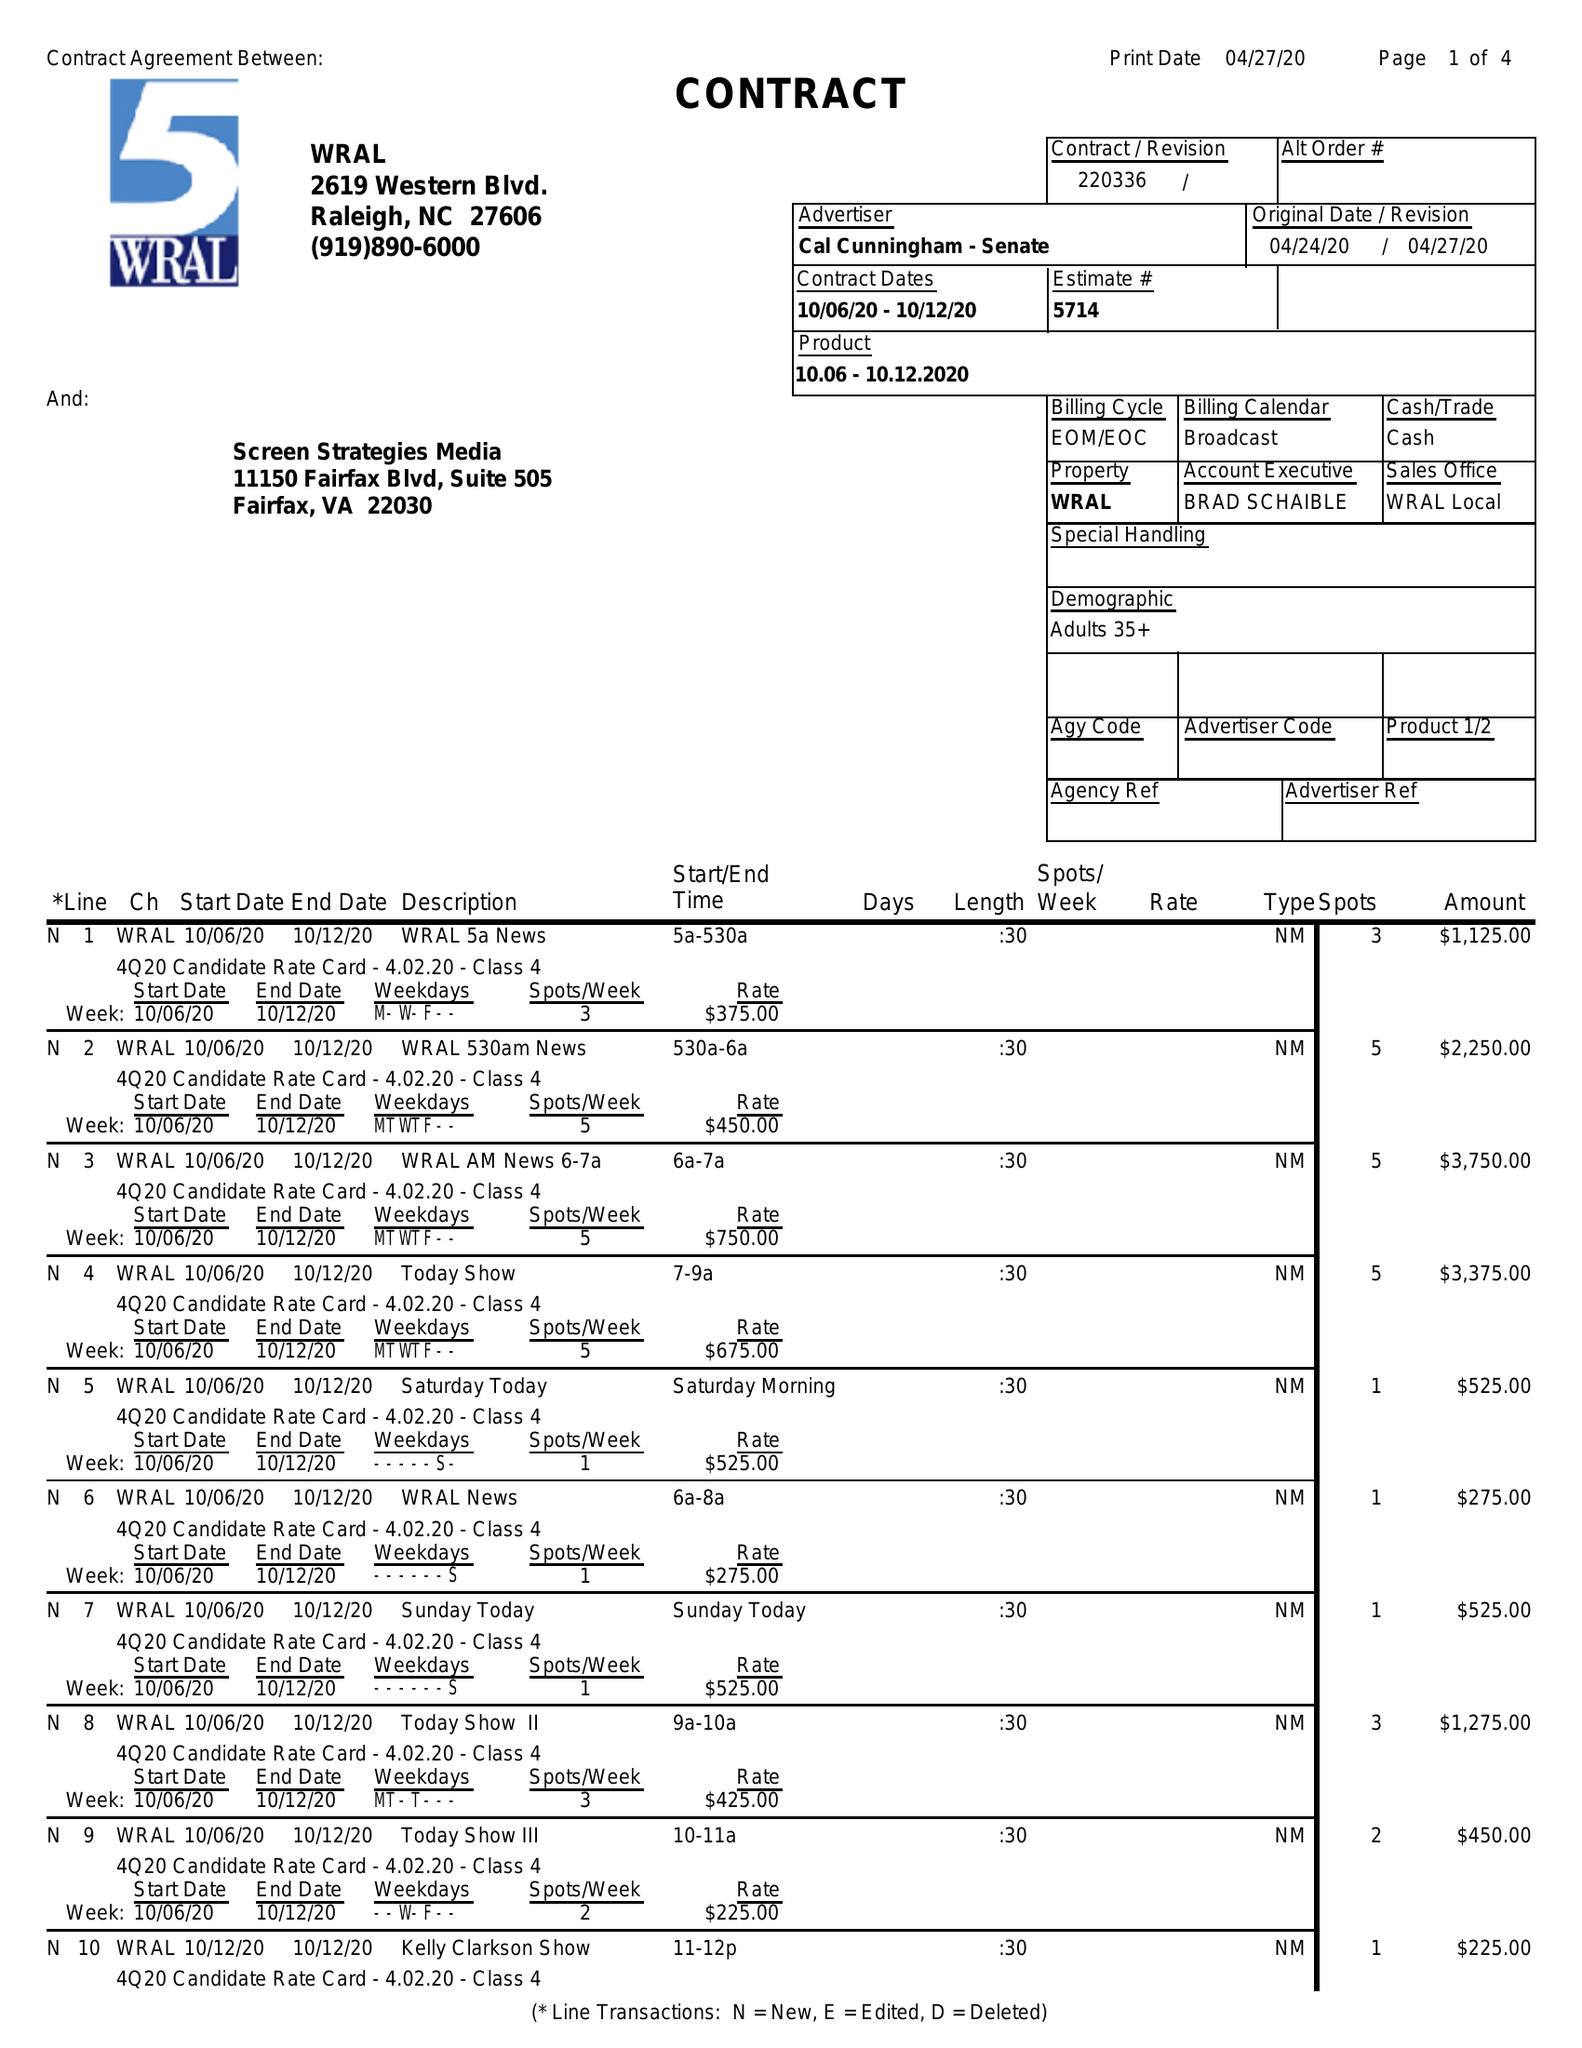What is the value for the gross_amount?
Answer the question using a single word or phrase. 64400.00 